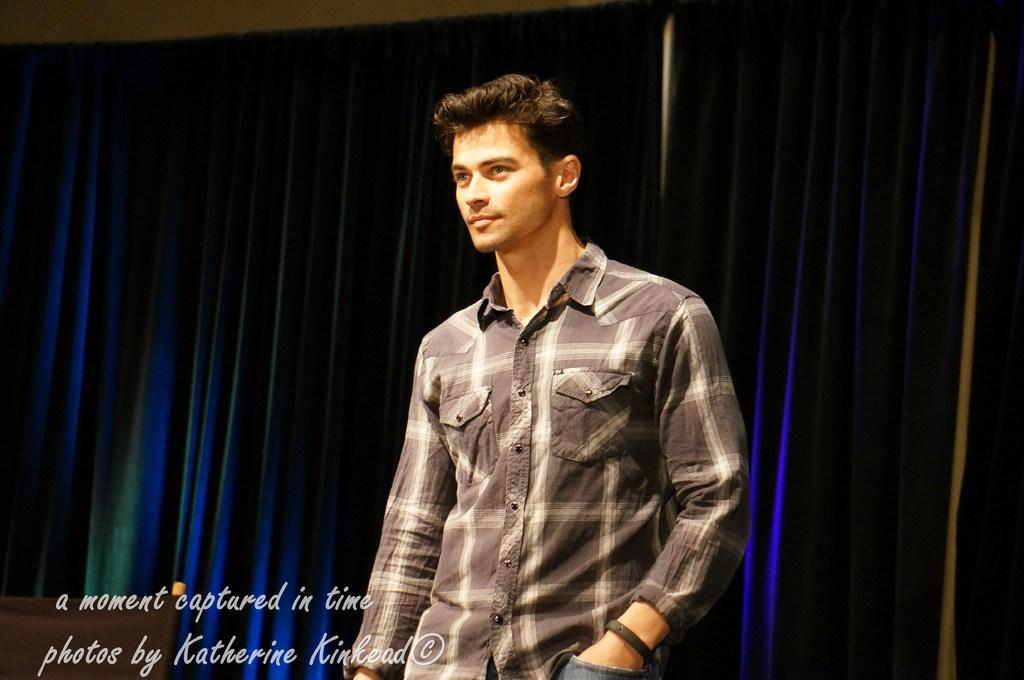What is the main subject of the image? There is a man standing in the center of the image. What can be seen in the background of the image? There is a wall and curtains in the background of the image. Is there any text present in the image? Yes, there is some text at the bottom of the image. What type of pancake is being served to the man in the image? There is no pancake present in the image; the man is standing and not eating or being served any food. 